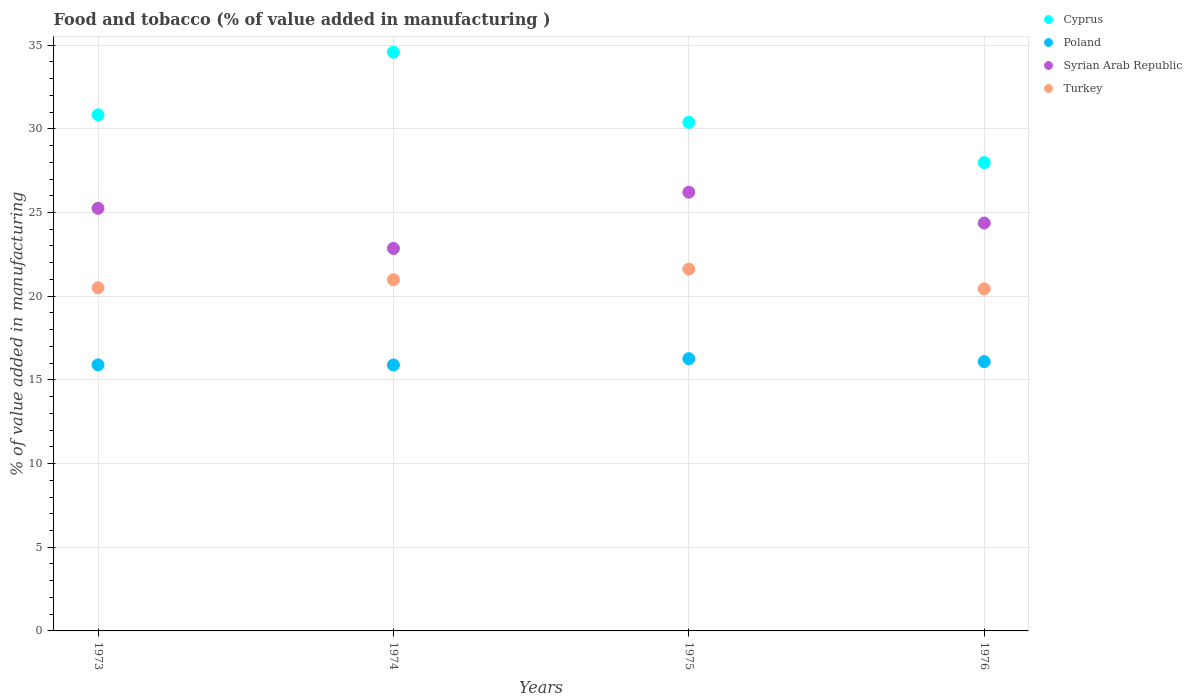How many different coloured dotlines are there?
Provide a succinct answer. 4. What is the value added in manufacturing food and tobacco in Turkey in 1973?
Provide a succinct answer. 20.5. Across all years, what is the maximum value added in manufacturing food and tobacco in Syrian Arab Republic?
Your answer should be compact. 26.21. Across all years, what is the minimum value added in manufacturing food and tobacco in Poland?
Provide a succinct answer. 15.89. In which year was the value added in manufacturing food and tobacco in Poland maximum?
Offer a terse response. 1975. In which year was the value added in manufacturing food and tobacco in Cyprus minimum?
Your answer should be compact. 1976. What is the total value added in manufacturing food and tobacco in Syrian Arab Republic in the graph?
Your answer should be very brief. 98.69. What is the difference between the value added in manufacturing food and tobacco in Poland in 1974 and that in 1975?
Your answer should be compact. -0.38. What is the difference between the value added in manufacturing food and tobacco in Syrian Arab Republic in 1975 and the value added in manufacturing food and tobacco in Turkey in 1976?
Make the answer very short. 5.77. What is the average value added in manufacturing food and tobacco in Syrian Arab Republic per year?
Offer a very short reply. 24.67. In the year 1974, what is the difference between the value added in manufacturing food and tobacco in Turkey and value added in manufacturing food and tobacco in Syrian Arab Republic?
Your response must be concise. -1.87. What is the ratio of the value added in manufacturing food and tobacco in Syrian Arab Republic in 1973 to that in 1976?
Your answer should be compact. 1.04. Is the difference between the value added in manufacturing food and tobacco in Turkey in 1975 and 1976 greater than the difference between the value added in manufacturing food and tobacco in Syrian Arab Republic in 1975 and 1976?
Ensure brevity in your answer.  No. What is the difference between the highest and the second highest value added in manufacturing food and tobacco in Poland?
Ensure brevity in your answer.  0.17. What is the difference between the highest and the lowest value added in manufacturing food and tobacco in Turkey?
Your answer should be very brief. 1.18. In how many years, is the value added in manufacturing food and tobacco in Syrian Arab Republic greater than the average value added in manufacturing food and tobacco in Syrian Arab Republic taken over all years?
Your answer should be very brief. 2. Is it the case that in every year, the sum of the value added in manufacturing food and tobacco in Cyprus and value added in manufacturing food and tobacco in Syrian Arab Republic  is greater than the sum of value added in manufacturing food and tobacco in Turkey and value added in manufacturing food and tobacco in Poland?
Your response must be concise. Yes. How many dotlines are there?
Keep it short and to the point. 4. What is the difference between two consecutive major ticks on the Y-axis?
Make the answer very short. 5. How many legend labels are there?
Offer a terse response. 4. How are the legend labels stacked?
Offer a terse response. Vertical. What is the title of the graph?
Give a very brief answer. Food and tobacco (% of value added in manufacturing ). What is the label or title of the X-axis?
Make the answer very short. Years. What is the label or title of the Y-axis?
Give a very brief answer. % of value added in manufacturing. What is the % of value added in manufacturing in Cyprus in 1973?
Keep it short and to the point. 30.84. What is the % of value added in manufacturing of Poland in 1973?
Give a very brief answer. 15.9. What is the % of value added in manufacturing in Syrian Arab Republic in 1973?
Make the answer very short. 25.25. What is the % of value added in manufacturing in Turkey in 1973?
Offer a very short reply. 20.5. What is the % of value added in manufacturing of Cyprus in 1974?
Ensure brevity in your answer.  34.58. What is the % of value added in manufacturing in Poland in 1974?
Your answer should be very brief. 15.89. What is the % of value added in manufacturing in Syrian Arab Republic in 1974?
Provide a short and direct response. 22.85. What is the % of value added in manufacturing of Turkey in 1974?
Make the answer very short. 20.98. What is the % of value added in manufacturing in Cyprus in 1975?
Your response must be concise. 30.39. What is the % of value added in manufacturing of Poland in 1975?
Your answer should be compact. 16.27. What is the % of value added in manufacturing of Syrian Arab Republic in 1975?
Provide a succinct answer. 26.21. What is the % of value added in manufacturing in Turkey in 1975?
Provide a short and direct response. 21.62. What is the % of value added in manufacturing of Cyprus in 1976?
Give a very brief answer. 27.98. What is the % of value added in manufacturing of Poland in 1976?
Keep it short and to the point. 16.09. What is the % of value added in manufacturing in Syrian Arab Republic in 1976?
Your answer should be compact. 24.37. What is the % of value added in manufacturing of Turkey in 1976?
Provide a short and direct response. 20.44. Across all years, what is the maximum % of value added in manufacturing in Cyprus?
Provide a short and direct response. 34.58. Across all years, what is the maximum % of value added in manufacturing of Poland?
Give a very brief answer. 16.27. Across all years, what is the maximum % of value added in manufacturing of Syrian Arab Republic?
Make the answer very short. 26.21. Across all years, what is the maximum % of value added in manufacturing in Turkey?
Your answer should be compact. 21.62. Across all years, what is the minimum % of value added in manufacturing of Cyprus?
Your answer should be very brief. 27.98. Across all years, what is the minimum % of value added in manufacturing of Poland?
Give a very brief answer. 15.89. Across all years, what is the minimum % of value added in manufacturing of Syrian Arab Republic?
Offer a terse response. 22.85. Across all years, what is the minimum % of value added in manufacturing of Turkey?
Your response must be concise. 20.44. What is the total % of value added in manufacturing of Cyprus in the graph?
Give a very brief answer. 123.79. What is the total % of value added in manufacturing in Poland in the graph?
Offer a very short reply. 64.15. What is the total % of value added in manufacturing in Syrian Arab Republic in the graph?
Your response must be concise. 98.69. What is the total % of value added in manufacturing of Turkey in the graph?
Give a very brief answer. 83.54. What is the difference between the % of value added in manufacturing of Cyprus in 1973 and that in 1974?
Offer a terse response. -3.74. What is the difference between the % of value added in manufacturing in Poland in 1973 and that in 1974?
Your answer should be very brief. 0.01. What is the difference between the % of value added in manufacturing of Syrian Arab Republic in 1973 and that in 1974?
Offer a very short reply. 2.4. What is the difference between the % of value added in manufacturing of Turkey in 1973 and that in 1974?
Ensure brevity in your answer.  -0.48. What is the difference between the % of value added in manufacturing in Cyprus in 1973 and that in 1975?
Provide a short and direct response. 0.45. What is the difference between the % of value added in manufacturing of Poland in 1973 and that in 1975?
Provide a succinct answer. -0.37. What is the difference between the % of value added in manufacturing in Syrian Arab Republic in 1973 and that in 1975?
Ensure brevity in your answer.  -0.96. What is the difference between the % of value added in manufacturing of Turkey in 1973 and that in 1975?
Your answer should be very brief. -1.12. What is the difference between the % of value added in manufacturing in Cyprus in 1973 and that in 1976?
Provide a succinct answer. 2.85. What is the difference between the % of value added in manufacturing in Poland in 1973 and that in 1976?
Offer a terse response. -0.2. What is the difference between the % of value added in manufacturing of Turkey in 1973 and that in 1976?
Provide a succinct answer. 0.06. What is the difference between the % of value added in manufacturing of Cyprus in 1974 and that in 1975?
Provide a short and direct response. 4.19. What is the difference between the % of value added in manufacturing in Poland in 1974 and that in 1975?
Your response must be concise. -0.38. What is the difference between the % of value added in manufacturing in Syrian Arab Republic in 1974 and that in 1975?
Make the answer very short. -3.36. What is the difference between the % of value added in manufacturing in Turkey in 1974 and that in 1975?
Your response must be concise. -0.64. What is the difference between the % of value added in manufacturing in Cyprus in 1974 and that in 1976?
Ensure brevity in your answer.  6.6. What is the difference between the % of value added in manufacturing in Poland in 1974 and that in 1976?
Provide a short and direct response. -0.2. What is the difference between the % of value added in manufacturing of Syrian Arab Republic in 1974 and that in 1976?
Make the answer very short. -1.52. What is the difference between the % of value added in manufacturing of Turkey in 1974 and that in 1976?
Keep it short and to the point. 0.54. What is the difference between the % of value added in manufacturing of Cyprus in 1975 and that in 1976?
Your answer should be compact. 2.4. What is the difference between the % of value added in manufacturing of Poland in 1975 and that in 1976?
Provide a succinct answer. 0.17. What is the difference between the % of value added in manufacturing of Syrian Arab Republic in 1975 and that in 1976?
Your response must be concise. 1.84. What is the difference between the % of value added in manufacturing of Turkey in 1975 and that in 1976?
Your answer should be very brief. 1.18. What is the difference between the % of value added in manufacturing of Cyprus in 1973 and the % of value added in manufacturing of Poland in 1974?
Your answer should be very brief. 14.95. What is the difference between the % of value added in manufacturing of Cyprus in 1973 and the % of value added in manufacturing of Syrian Arab Republic in 1974?
Provide a short and direct response. 7.98. What is the difference between the % of value added in manufacturing in Cyprus in 1973 and the % of value added in manufacturing in Turkey in 1974?
Your answer should be compact. 9.86. What is the difference between the % of value added in manufacturing of Poland in 1973 and the % of value added in manufacturing of Syrian Arab Republic in 1974?
Offer a very short reply. -6.96. What is the difference between the % of value added in manufacturing of Poland in 1973 and the % of value added in manufacturing of Turkey in 1974?
Your answer should be very brief. -5.09. What is the difference between the % of value added in manufacturing in Syrian Arab Republic in 1973 and the % of value added in manufacturing in Turkey in 1974?
Your response must be concise. 4.27. What is the difference between the % of value added in manufacturing of Cyprus in 1973 and the % of value added in manufacturing of Poland in 1975?
Keep it short and to the point. 14.57. What is the difference between the % of value added in manufacturing of Cyprus in 1973 and the % of value added in manufacturing of Syrian Arab Republic in 1975?
Give a very brief answer. 4.62. What is the difference between the % of value added in manufacturing in Cyprus in 1973 and the % of value added in manufacturing in Turkey in 1975?
Provide a succinct answer. 9.22. What is the difference between the % of value added in manufacturing in Poland in 1973 and the % of value added in manufacturing in Syrian Arab Republic in 1975?
Ensure brevity in your answer.  -10.32. What is the difference between the % of value added in manufacturing in Poland in 1973 and the % of value added in manufacturing in Turkey in 1975?
Your response must be concise. -5.72. What is the difference between the % of value added in manufacturing of Syrian Arab Republic in 1973 and the % of value added in manufacturing of Turkey in 1975?
Provide a short and direct response. 3.63. What is the difference between the % of value added in manufacturing of Cyprus in 1973 and the % of value added in manufacturing of Poland in 1976?
Your answer should be compact. 14.75. What is the difference between the % of value added in manufacturing in Cyprus in 1973 and the % of value added in manufacturing in Syrian Arab Republic in 1976?
Your answer should be very brief. 6.47. What is the difference between the % of value added in manufacturing of Cyprus in 1973 and the % of value added in manufacturing of Turkey in 1976?
Your response must be concise. 10.4. What is the difference between the % of value added in manufacturing in Poland in 1973 and the % of value added in manufacturing in Syrian Arab Republic in 1976?
Make the answer very short. -8.47. What is the difference between the % of value added in manufacturing in Poland in 1973 and the % of value added in manufacturing in Turkey in 1976?
Provide a short and direct response. -4.54. What is the difference between the % of value added in manufacturing of Syrian Arab Republic in 1973 and the % of value added in manufacturing of Turkey in 1976?
Offer a terse response. 4.81. What is the difference between the % of value added in manufacturing in Cyprus in 1974 and the % of value added in manufacturing in Poland in 1975?
Make the answer very short. 18.31. What is the difference between the % of value added in manufacturing in Cyprus in 1974 and the % of value added in manufacturing in Syrian Arab Republic in 1975?
Keep it short and to the point. 8.37. What is the difference between the % of value added in manufacturing of Cyprus in 1974 and the % of value added in manufacturing of Turkey in 1975?
Offer a very short reply. 12.96. What is the difference between the % of value added in manufacturing of Poland in 1974 and the % of value added in manufacturing of Syrian Arab Republic in 1975?
Provide a short and direct response. -10.32. What is the difference between the % of value added in manufacturing in Poland in 1974 and the % of value added in manufacturing in Turkey in 1975?
Provide a short and direct response. -5.73. What is the difference between the % of value added in manufacturing in Syrian Arab Republic in 1974 and the % of value added in manufacturing in Turkey in 1975?
Offer a very short reply. 1.24. What is the difference between the % of value added in manufacturing of Cyprus in 1974 and the % of value added in manufacturing of Poland in 1976?
Your answer should be compact. 18.49. What is the difference between the % of value added in manufacturing in Cyprus in 1974 and the % of value added in manufacturing in Syrian Arab Republic in 1976?
Your answer should be compact. 10.21. What is the difference between the % of value added in manufacturing in Cyprus in 1974 and the % of value added in manufacturing in Turkey in 1976?
Give a very brief answer. 14.14. What is the difference between the % of value added in manufacturing in Poland in 1974 and the % of value added in manufacturing in Syrian Arab Republic in 1976?
Provide a succinct answer. -8.48. What is the difference between the % of value added in manufacturing in Poland in 1974 and the % of value added in manufacturing in Turkey in 1976?
Ensure brevity in your answer.  -4.55. What is the difference between the % of value added in manufacturing of Syrian Arab Republic in 1974 and the % of value added in manufacturing of Turkey in 1976?
Your answer should be very brief. 2.42. What is the difference between the % of value added in manufacturing in Cyprus in 1975 and the % of value added in manufacturing in Poland in 1976?
Your answer should be compact. 14.29. What is the difference between the % of value added in manufacturing of Cyprus in 1975 and the % of value added in manufacturing of Syrian Arab Republic in 1976?
Your answer should be compact. 6.02. What is the difference between the % of value added in manufacturing in Cyprus in 1975 and the % of value added in manufacturing in Turkey in 1976?
Offer a terse response. 9.95. What is the difference between the % of value added in manufacturing in Poland in 1975 and the % of value added in manufacturing in Syrian Arab Republic in 1976?
Provide a succinct answer. -8.1. What is the difference between the % of value added in manufacturing of Poland in 1975 and the % of value added in manufacturing of Turkey in 1976?
Provide a short and direct response. -4.17. What is the difference between the % of value added in manufacturing of Syrian Arab Republic in 1975 and the % of value added in manufacturing of Turkey in 1976?
Provide a succinct answer. 5.77. What is the average % of value added in manufacturing in Cyprus per year?
Your answer should be compact. 30.95. What is the average % of value added in manufacturing in Poland per year?
Provide a succinct answer. 16.04. What is the average % of value added in manufacturing in Syrian Arab Republic per year?
Keep it short and to the point. 24.67. What is the average % of value added in manufacturing in Turkey per year?
Keep it short and to the point. 20.89. In the year 1973, what is the difference between the % of value added in manufacturing of Cyprus and % of value added in manufacturing of Poland?
Give a very brief answer. 14.94. In the year 1973, what is the difference between the % of value added in manufacturing of Cyprus and % of value added in manufacturing of Syrian Arab Republic?
Make the answer very short. 5.59. In the year 1973, what is the difference between the % of value added in manufacturing in Cyprus and % of value added in manufacturing in Turkey?
Ensure brevity in your answer.  10.34. In the year 1973, what is the difference between the % of value added in manufacturing of Poland and % of value added in manufacturing of Syrian Arab Republic?
Your answer should be very brief. -9.35. In the year 1973, what is the difference between the % of value added in manufacturing of Poland and % of value added in manufacturing of Turkey?
Keep it short and to the point. -4.61. In the year 1973, what is the difference between the % of value added in manufacturing of Syrian Arab Republic and % of value added in manufacturing of Turkey?
Offer a terse response. 4.75. In the year 1974, what is the difference between the % of value added in manufacturing of Cyprus and % of value added in manufacturing of Poland?
Your answer should be very brief. 18.69. In the year 1974, what is the difference between the % of value added in manufacturing of Cyprus and % of value added in manufacturing of Syrian Arab Republic?
Give a very brief answer. 11.72. In the year 1974, what is the difference between the % of value added in manufacturing of Cyprus and % of value added in manufacturing of Turkey?
Provide a succinct answer. 13.6. In the year 1974, what is the difference between the % of value added in manufacturing of Poland and % of value added in manufacturing of Syrian Arab Republic?
Keep it short and to the point. -6.96. In the year 1974, what is the difference between the % of value added in manufacturing of Poland and % of value added in manufacturing of Turkey?
Keep it short and to the point. -5.09. In the year 1974, what is the difference between the % of value added in manufacturing of Syrian Arab Republic and % of value added in manufacturing of Turkey?
Offer a terse response. 1.87. In the year 1975, what is the difference between the % of value added in manufacturing of Cyprus and % of value added in manufacturing of Poland?
Provide a short and direct response. 14.12. In the year 1975, what is the difference between the % of value added in manufacturing of Cyprus and % of value added in manufacturing of Syrian Arab Republic?
Your response must be concise. 4.17. In the year 1975, what is the difference between the % of value added in manufacturing in Cyprus and % of value added in manufacturing in Turkey?
Ensure brevity in your answer.  8.77. In the year 1975, what is the difference between the % of value added in manufacturing of Poland and % of value added in manufacturing of Syrian Arab Republic?
Your response must be concise. -9.95. In the year 1975, what is the difference between the % of value added in manufacturing of Poland and % of value added in manufacturing of Turkey?
Your answer should be compact. -5.35. In the year 1975, what is the difference between the % of value added in manufacturing of Syrian Arab Republic and % of value added in manufacturing of Turkey?
Ensure brevity in your answer.  4.59. In the year 1976, what is the difference between the % of value added in manufacturing of Cyprus and % of value added in manufacturing of Poland?
Your answer should be compact. 11.89. In the year 1976, what is the difference between the % of value added in manufacturing in Cyprus and % of value added in manufacturing in Syrian Arab Republic?
Make the answer very short. 3.61. In the year 1976, what is the difference between the % of value added in manufacturing of Cyprus and % of value added in manufacturing of Turkey?
Your answer should be very brief. 7.54. In the year 1976, what is the difference between the % of value added in manufacturing of Poland and % of value added in manufacturing of Syrian Arab Republic?
Ensure brevity in your answer.  -8.28. In the year 1976, what is the difference between the % of value added in manufacturing in Poland and % of value added in manufacturing in Turkey?
Make the answer very short. -4.35. In the year 1976, what is the difference between the % of value added in manufacturing in Syrian Arab Republic and % of value added in manufacturing in Turkey?
Give a very brief answer. 3.93. What is the ratio of the % of value added in manufacturing of Cyprus in 1973 to that in 1974?
Give a very brief answer. 0.89. What is the ratio of the % of value added in manufacturing in Poland in 1973 to that in 1974?
Provide a short and direct response. 1. What is the ratio of the % of value added in manufacturing of Syrian Arab Republic in 1973 to that in 1974?
Make the answer very short. 1.1. What is the ratio of the % of value added in manufacturing of Turkey in 1973 to that in 1974?
Offer a very short reply. 0.98. What is the ratio of the % of value added in manufacturing in Cyprus in 1973 to that in 1975?
Make the answer very short. 1.01. What is the ratio of the % of value added in manufacturing of Poland in 1973 to that in 1975?
Ensure brevity in your answer.  0.98. What is the ratio of the % of value added in manufacturing in Syrian Arab Republic in 1973 to that in 1975?
Provide a short and direct response. 0.96. What is the ratio of the % of value added in manufacturing of Turkey in 1973 to that in 1975?
Your answer should be very brief. 0.95. What is the ratio of the % of value added in manufacturing in Cyprus in 1973 to that in 1976?
Keep it short and to the point. 1.1. What is the ratio of the % of value added in manufacturing of Poland in 1973 to that in 1976?
Keep it short and to the point. 0.99. What is the ratio of the % of value added in manufacturing of Syrian Arab Republic in 1973 to that in 1976?
Provide a short and direct response. 1.04. What is the ratio of the % of value added in manufacturing of Turkey in 1973 to that in 1976?
Your answer should be compact. 1. What is the ratio of the % of value added in manufacturing of Cyprus in 1974 to that in 1975?
Your answer should be compact. 1.14. What is the ratio of the % of value added in manufacturing of Poland in 1974 to that in 1975?
Your answer should be compact. 0.98. What is the ratio of the % of value added in manufacturing of Syrian Arab Republic in 1974 to that in 1975?
Provide a succinct answer. 0.87. What is the ratio of the % of value added in manufacturing of Turkey in 1974 to that in 1975?
Your answer should be very brief. 0.97. What is the ratio of the % of value added in manufacturing in Cyprus in 1974 to that in 1976?
Your answer should be compact. 1.24. What is the ratio of the % of value added in manufacturing in Poland in 1974 to that in 1976?
Your answer should be compact. 0.99. What is the ratio of the % of value added in manufacturing in Syrian Arab Republic in 1974 to that in 1976?
Your answer should be compact. 0.94. What is the ratio of the % of value added in manufacturing of Turkey in 1974 to that in 1976?
Your answer should be very brief. 1.03. What is the ratio of the % of value added in manufacturing in Cyprus in 1975 to that in 1976?
Ensure brevity in your answer.  1.09. What is the ratio of the % of value added in manufacturing of Poland in 1975 to that in 1976?
Keep it short and to the point. 1.01. What is the ratio of the % of value added in manufacturing in Syrian Arab Republic in 1975 to that in 1976?
Make the answer very short. 1.08. What is the ratio of the % of value added in manufacturing in Turkey in 1975 to that in 1976?
Offer a very short reply. 1.06. What is the difference between the highest and the second highest % of value added in manufacturing of Cyprus?
Ensure brevity in your answer.  3.74. What is the difference between the highest and the second highest % of value added in manufacturing of Poland?
Provide a succinct answer. 0.17. What is the difference between the highest and the second highest % of value added in manufacturing of Syrian Arab Republic?
Your answer should be compact. 0.96. What is the difference between the highest and the second highest % of value added in manufacturing in Turkey?
Offer a terse response. 0.64. What is the difference between the highest and the lowest % of value added in manufacturing of Cyprus?
Give a very brief answer. 6.6. What is the difference between the highest and the lowest % of value added in manufacturing in Poland?
Provide a succinct answer. 0.38. What is the difference between the highest and the lowest % of value added in manufacturing of Syrian Arab Republic?
Ensure brevity in your answer.  3.36. What is the difference between the highest and the lowest % of value added in manufacturing in Turkey?
Keep it short and to the point. 1.18. 